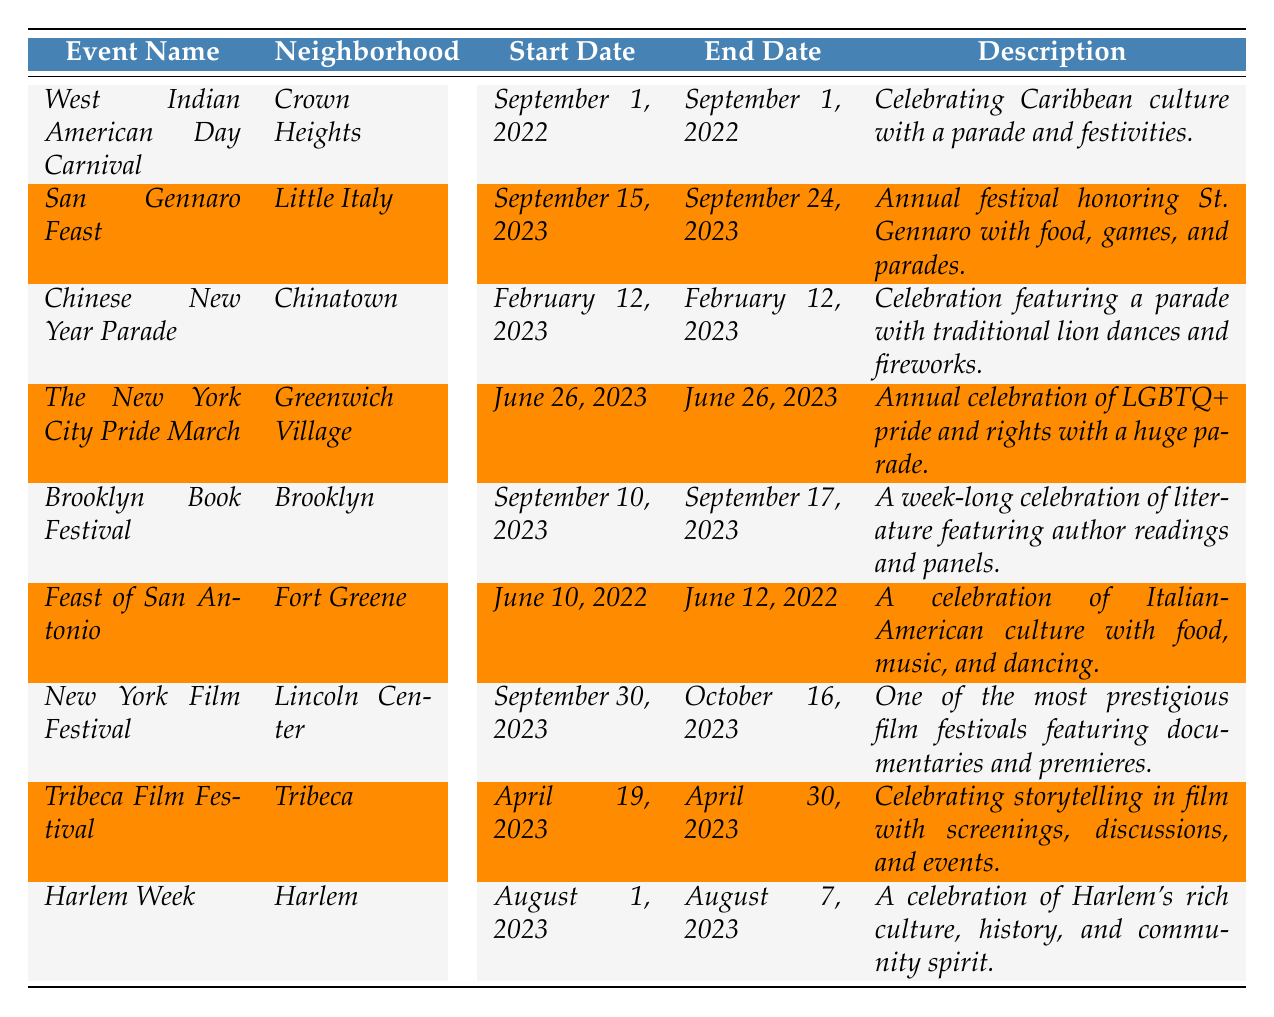What is the event taking place in Crown Heights? The table shows that the event in Crown Heights is the "West Indian American Day Carnival."
Answer: West Indian American Day Carnival How long does the San Gennaro Feast last? The San Gennaro Feast starts on September 15, 2023, and ends on September 24, 2023. This indicates it lasts for 10 days.
Answer: 10 days Is there an event celebrating LGBTQ+ pride in the table? Yes, the "New York City Pride March" on June 26, 2023, is designated as an annual celebration of LGBTQ+ pride and rights.
Answer: Yes Which event is the only one taking place in August? The only event in August is "Harlem Week," which runs from August 1, 2023, to August 7, 2023.
Answer: Harlem Week What is the total number of days for the Brooklyn Book Festival? The Brooklyn Book Festival starts on September 10, 2023, and ends on September 17, 2023, so it lasts for 8 days.
Answer: 8 days On which specific date does the Chinese New Year Parade occur? The table specifies that the Chinese New Year Parade occurs on February 12, 2023.
Answer: February 12, 2023 How many events listed are occurring in September? There are four events occurring in September: West Indian American Day Carnival, San Gennaro Feast, Brooklyn Book Festival, and New York Film Festival.
Answer: 4 events What is the description of the Tribeca Film Festival? The description states that the Tribeca Film Festival is celebrating storytelling in film with screenings, discussions, and events.
Answer: Celebrating storytelling in film Which neighborhood has the longest event duration? The San Gennaro Feast lasts for 10 days, which is the longest duration among all events listed.
Answer: Little Italy Are there any events taking place in Fort Greene? Yes, there is an event called the "Feast of San Antonio" taking place in Fort Greene from June 10 to June 12, 2022.
Answer: Yes 